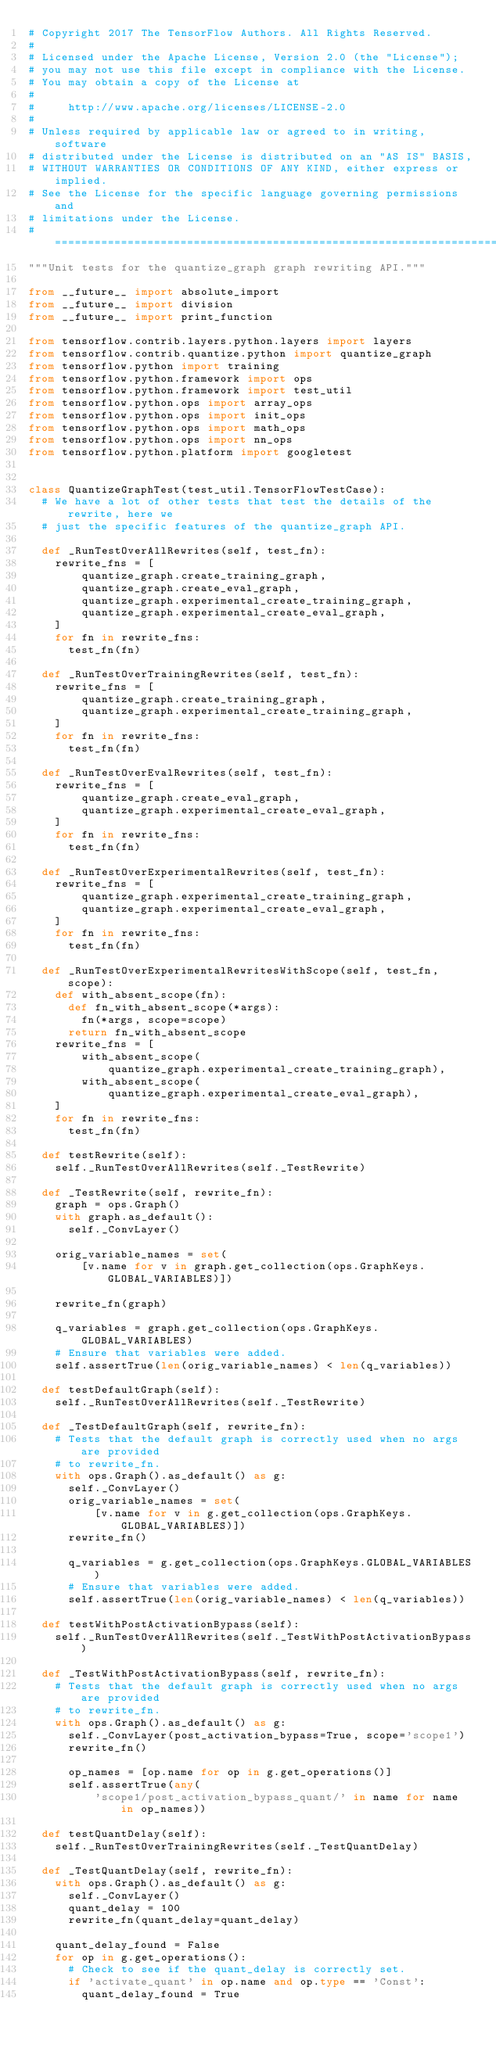Convert code to text. <code><loc_0><loc_0><loc_500><loc_500><_Python_># Copyright 2017 The TensorFlow Authors. All Rights Reserved.
#
# Licensed under the Apache License, Version 2.0 (the "License");
# you may not use this file except in compliance with the License.
# You may obtain a copy of the License at
#
#     http://www.apache.org/licenses/LICENSE-2.0
#
# Unless required by applicable law or agreed to in writing, software
# distributed under the License is distributed on an "AS IS" BASIS,
# WITHOUT WARRANTIES OR CONDITIONS OF ANY KIND, either express or implied.
# See the License for the specific language governing permissions and
# limitations under the License.
# ==============================================================================
"""Unit tests for the quantize_graph graph rewriting API."""

from __future__ import absolute_import
from __future__ import division
from __future__ import print_function

from tensorflow.contrib.layers.python.layers import layers
from tensorflow.contrib.quantize.python import quantize_graph
from tensorflow.python import training
from tensorflow.python.framework import ops
from tensorflow.python.framework import test_util
from tensorflow.python.ops import array_ops
from tensorflow.python.ops import init_ops
from tensorflow.python.ops import math_ops
from tensorflow.python.ops import nn_ops
from tensorflow.python.platform import googletest


class QuantizeGraphTest(test_util.TensorFlowTestCase):
  # We have a lot of other tests that test the details of the rewrite, here we
  # just the specific features of the quantize_graph API.

  def _RunTestOverAllRewrites(self, test_fn):
    rewrite_fns = [
        quantize_graph.create_training_graph,
        quantize_graph.create_eval_graph,
        quantize_graph.experimental_create_training_graph,
        quantize_graph.experimental_create_eval_graph,
    ]
    for fn in rewrite_fns:
      test_fn(fn)

  def _RunTestOverTrainingRewrites(self, test_fn):
    rewrite_fns = [
        quantize_graph.create_training_graph,
        quantize_graph.experimental_create_training_graph,
    ]
    for fn in rewrite_fns:
      test_fn(fn)

  def _RunTestOverEvalRewrites(self, test_fn):
    rewrite_fns = [
        quantize_graph.create_eval_graph,
        quantize_graph.experimental_create_eval_graph,
    ]
    for fn in rewrite_fns:
      test_fn(fn)

  def _RunTestOverExperimentalRewrites(self, test_fn):
    rewrite_fns = [
        quantize_graph.experimental_create_training_graph,
        quantize_graph.experimental_create_eval_graph,
    ]
    for fn in rewrite_fns:
      test_fn(fn)

  def _RunTestOverExperimentalRewritesWithScope(self, test_fn, scope):
    def with_absent_scope(fn):
      def fn_with_absent_scope(*args):
        fn(*args, scope=scope)
      return fn_with_absent_scope
    rewrite_fns = [
        with_absent_scope(
            quantize_graph.experimental_create_training_graph),
        with_absent_scope(
            quantize_graph.experimental_create_eval_graph),
    ]
    for fn in rewrite_fns:
      test_fn(fn)

  def testRewrite(self):
    self._RunTestOverAllRewrites(self._TestRewrite)

  def _TestRewrite(self, rewrite_fn):
    graph = ops.Graph()
    with graph.as_default():
      self._ConvLayer()

    orig_variable_names = set(
        [v.name for v in graph.get_collection(ops.GraphKeys.GLOBAL_VARIABLES)])

    rewrite_fn(graph)

    q_variables = graph.get_collection(ops.GraphKeys.GLOBAL_VARIABLES)
    # Ensure that variables were added.
    self.assertTrue(len(orig_variable_names) < len(q_variables))

  def testDefaultGraph(self):
    self._RunTestOverAllRewrites(self._TestRewrite)

  def _TestDefaultGraph(self, rewrite_fn):
    # Tests that the default graph is correctly used when no args are provided
    # to rewrite_fn.
    with ops.Graph().as_default() as g:
      self._ConvLayer()
      orig_variable_names = set(
          [v.name for v in g.get_collection(ops.GraphKeys.GLOBAL_VARIABLES)])
      rewrite_fn()

      q_variables = g.get_collection(ops.GraphKeys.GLOBAL_VARIABLES)
      # Ensure that variables were added.
      self.assertTrue(len(orig_variable_names) < len(q_variables))

  def testWithPostActivationBypass(self):
    self._RunTestOverAllRewrites(self._TestWithPostActivationBypass)

  def _TestWithPostActivationBypass(self, rewrite_fn):
    # Tests that the default graph is correctly used when no args are provided
    # to rewrite_fn.
    with ops.Graph().as_default() as g:
      self._ConvLayer(post_activation_bypass=True, scope='scope1')
      rewrite_fn()

      op_names = [op.name for op in g.get_operations()]
      self.assertTrue(any(
          'scope1/post_activation_bypass_quant/' in name for name in op_names))

  def testQuantDelay(self):
    self._RunTestOverTrainingRewrites(self._TestQuantDelay)

  def _TestQuantDelay(self, rewrite_fn):
    with ops.Graph().as_default() as g:
      self._ConvLayer()
      quant_delay = 100
      rewrite_fn(quant_delay=quant_delay)

    quant_delay_found = False
    for op in g.get_operations():
      # Check to see if the quant_delay is correctly set.
      if 'activate_quant' in op.name and op.type == 'Const':
        quant_delay_found = True</code> 